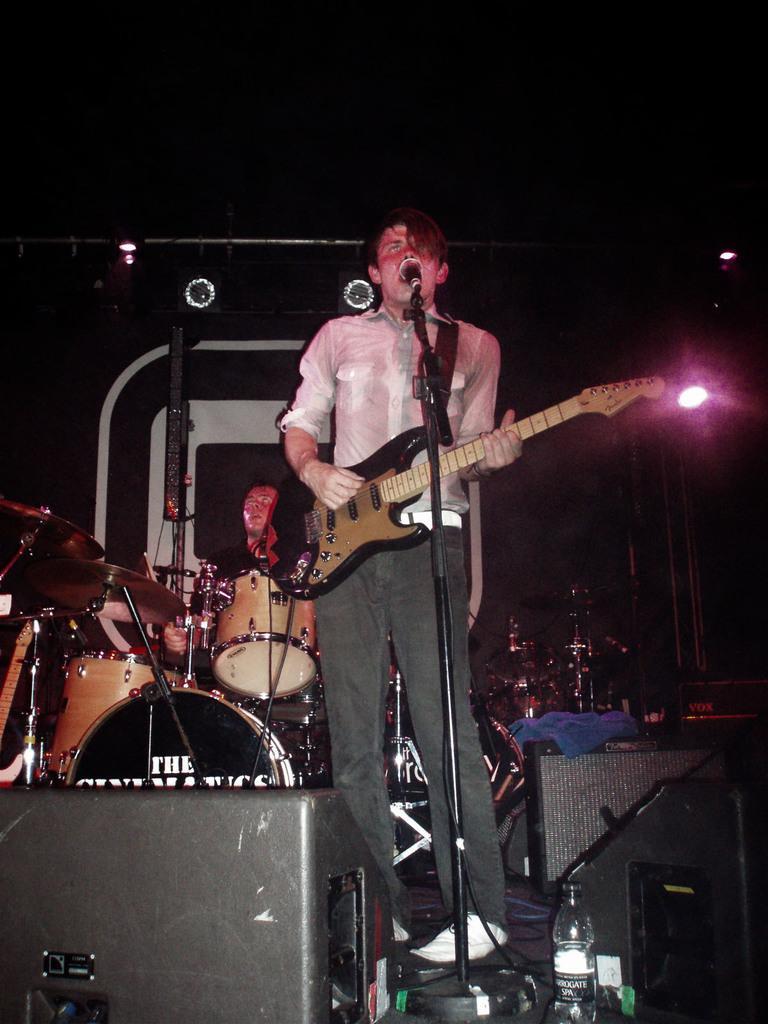Could you give a brief overview of what you see in this image? In the picture I can see a person wearing white shirt is playing guitar and singing in front of a mic and there is a person playing drums behind him and there are some other objects in front of him. 